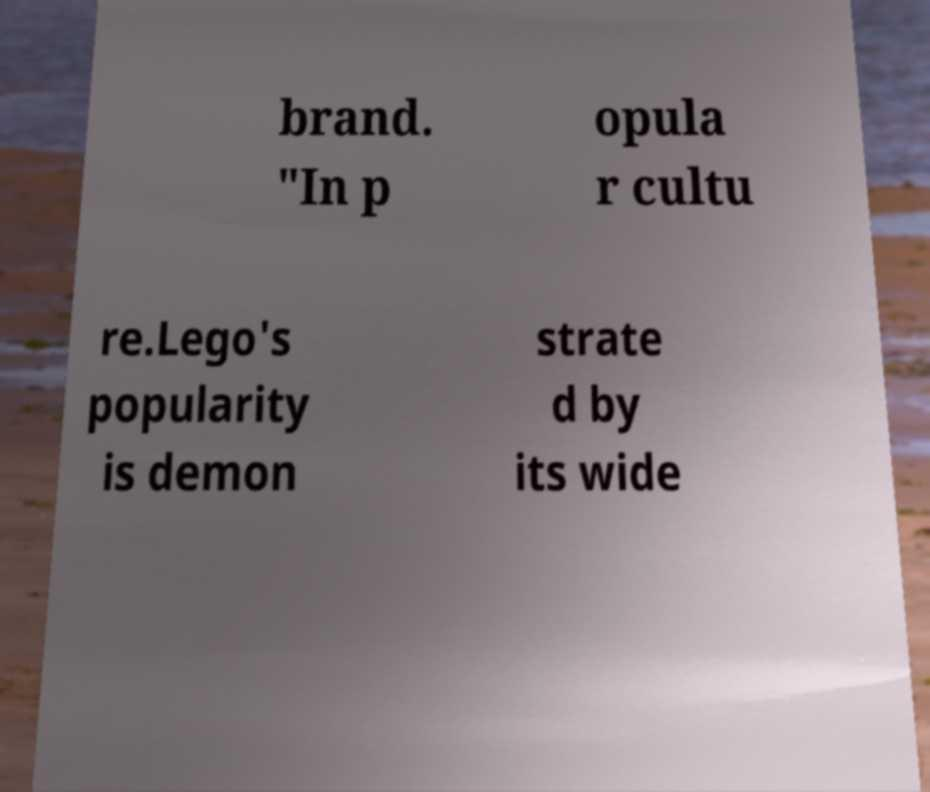Could you assist in decoding the text presented in this image and type it out clearly? brand. "In p opula r cultu re.Lego's popularity is demon strate d by its wide 